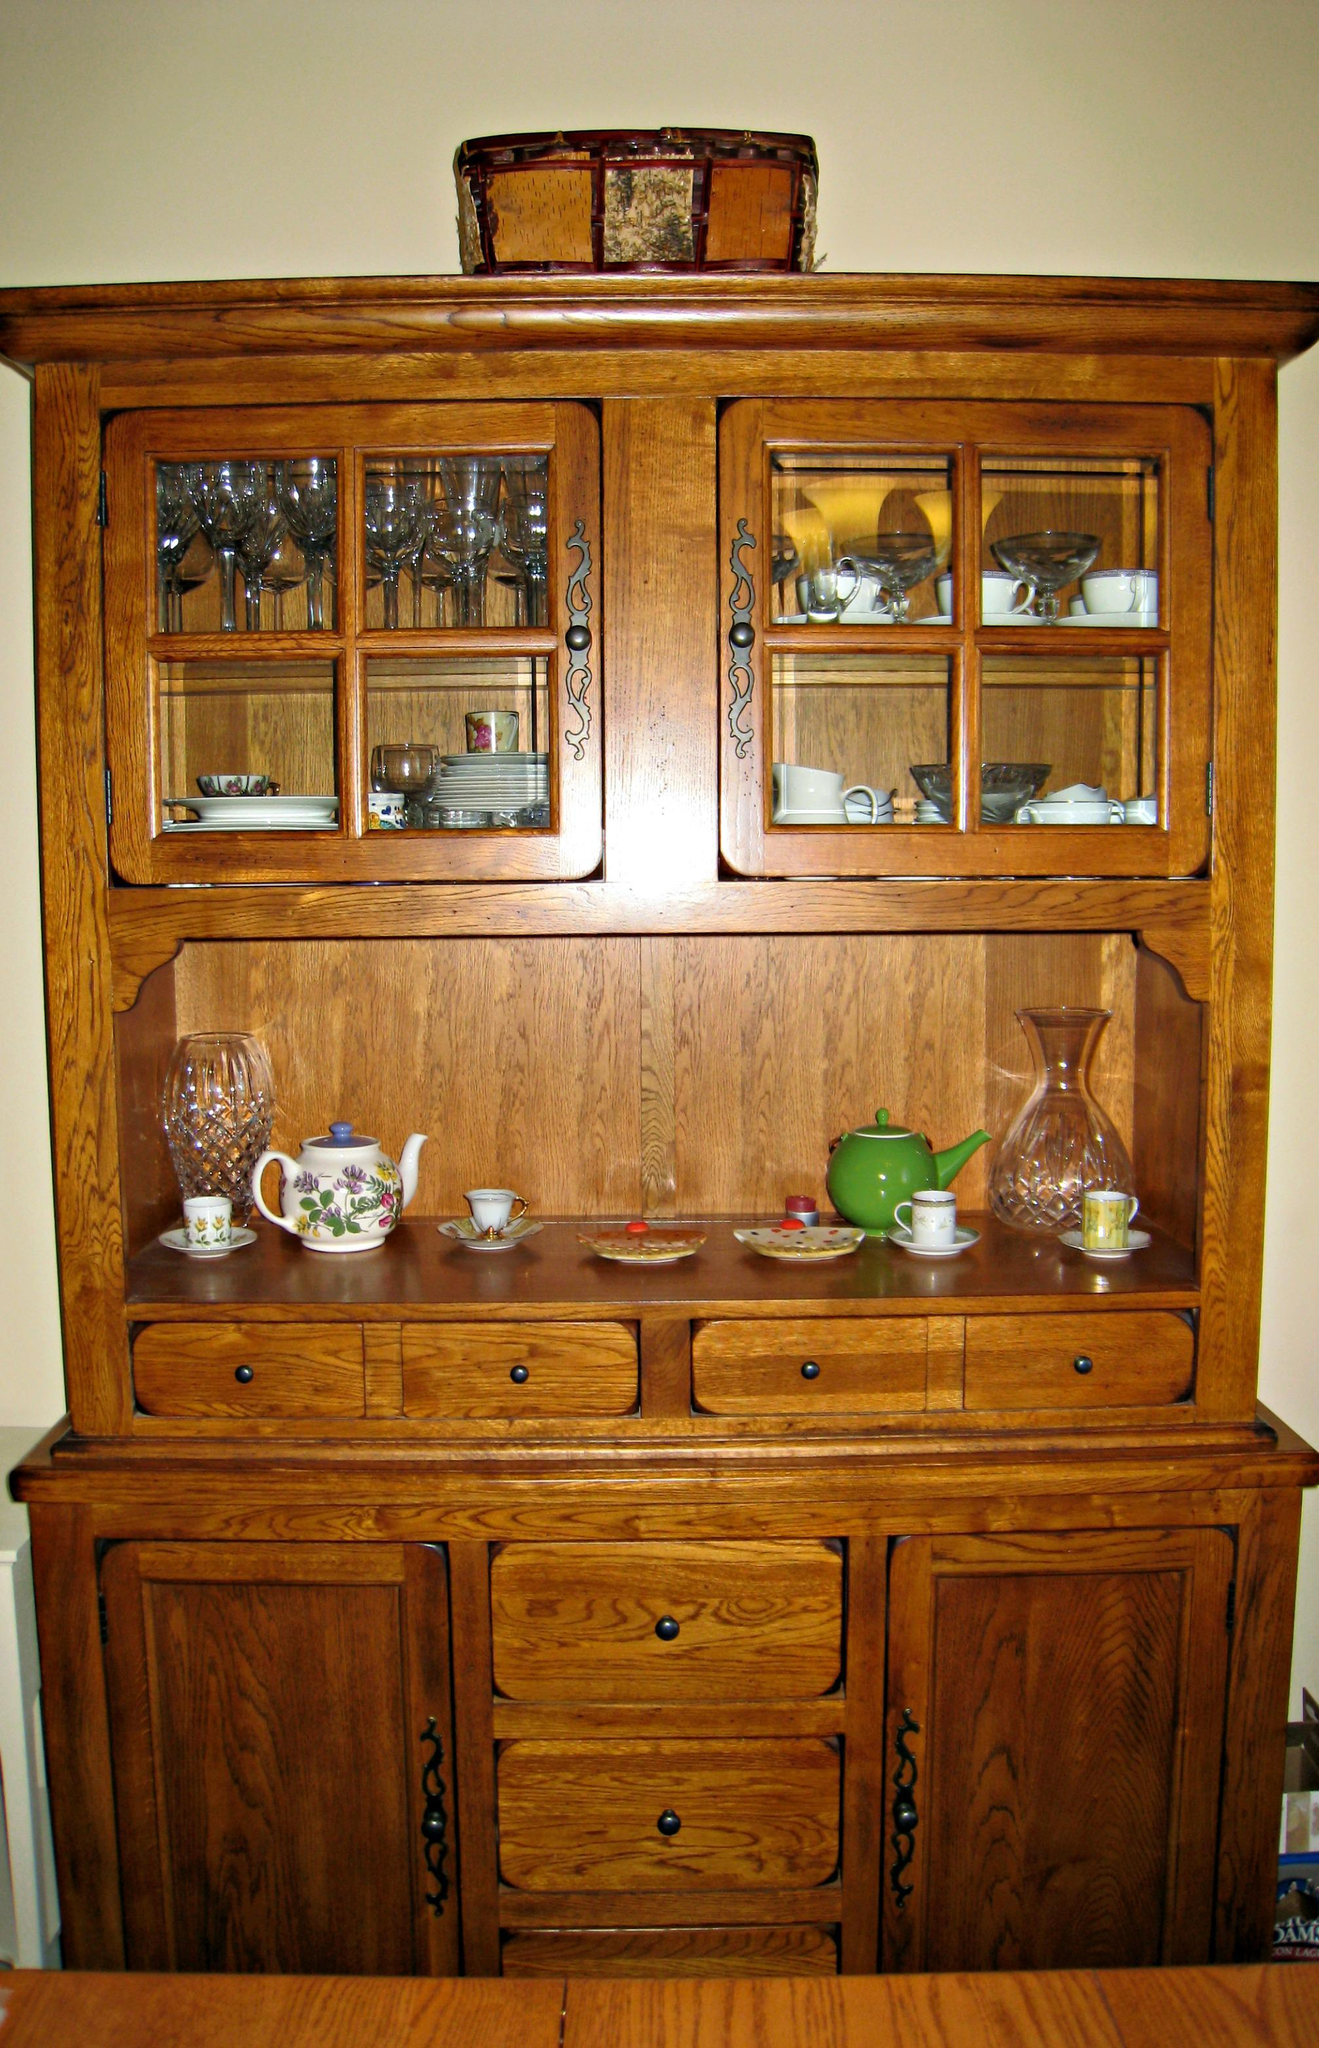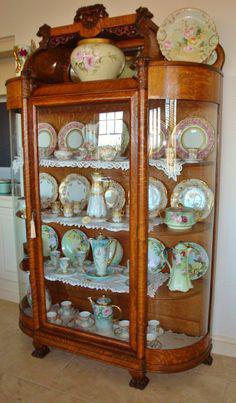The first image is the image on the left, the second image is the image on the right. Evaluate the accuracy of this statement regarding the images: "There is a plant resting on top of one of the furniture.". Is it true? Answer yes or no. No. The first image is the image on the left, the second image is the image on the right. Evaluate the accuracy of this statement regarding the images: "All china cabinets have solid doors and drawers at the bottom and glass fronted doors on top.". Is it true? Answer yes or no. No. 